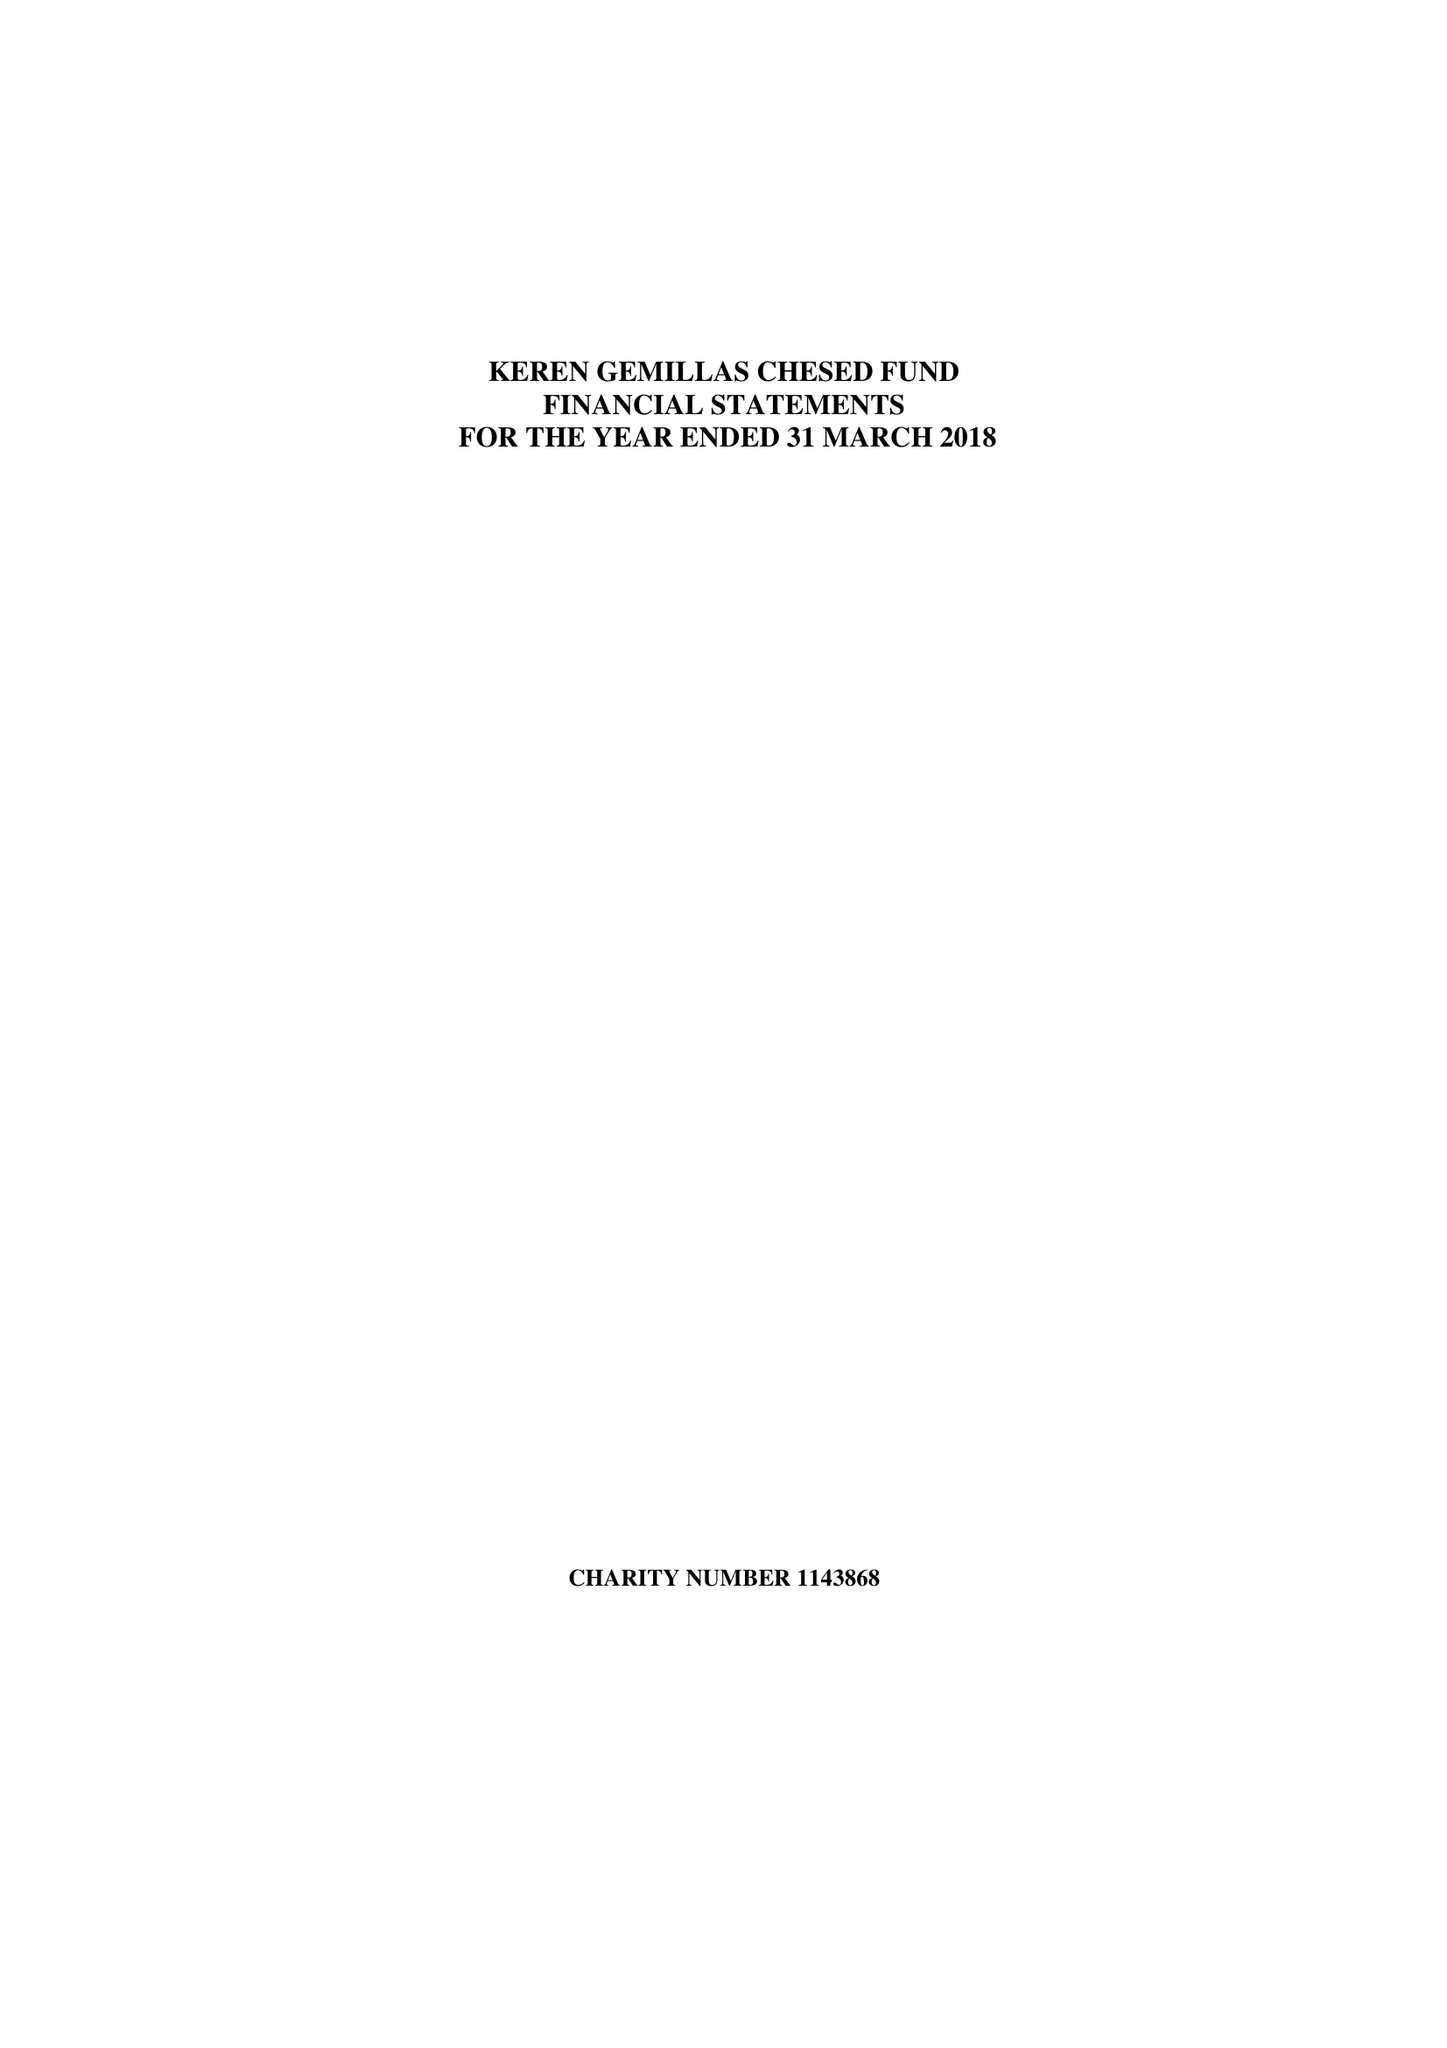What is the value for the spending_annually_in_british_pounds?
Answer the question using a single word or phrase. 113853.00 